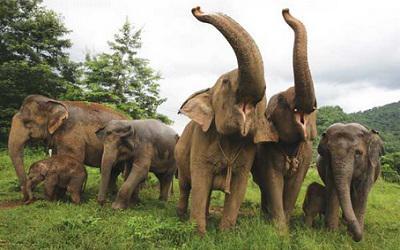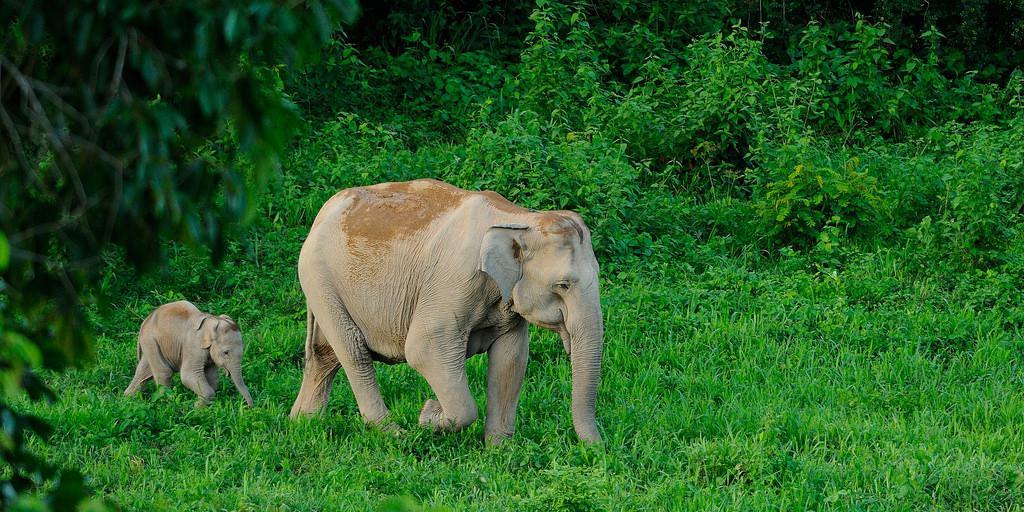The first image is the image on the left, the second image is the image on the right. For the images displayed, is the sentence "Two elephants, an adult and a baby, are walking through a grassy field." factually correct? Answer yes or no. Yes. The first image is the image on the left, the second image is the image on the right. Given the left and right images, does the statement "An image shows an elephant with tusks facing the camera." hold true? Answer yes or no. No. 